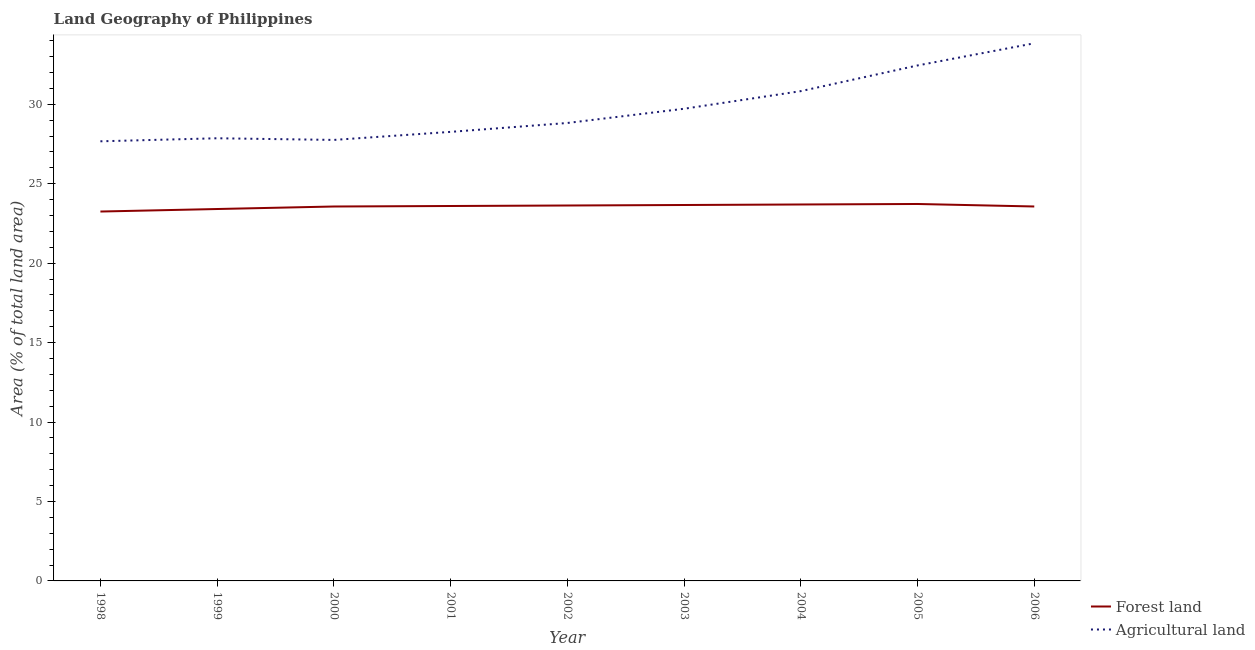Does the line corresponding to percentage of land area under forests intersect with the line corresponding to percentage of land area under agriculture?
Give a very brief answer. No. What is the percentage of land area under agriculture in 2004?
Give a very brief answer. 30.83. Across all years, what is the maximum percentage of land area under agriculture?
Offer a terse response. 33.84. Across all years, what is the minimum percentage of land area under forests?
Provide a succinct answer. 23.25. In which year was the percentage of land area under agriculture minimum?
Your response must be concise. 1998. What is the total percentage of land area under forests in the graph?
Ensure brevity in your answer.  212.1. What is the difference between the percentage of land area under agriculture in 1998 and that in 2002?
Provide a succinct answer. -1.15. What is the difference between the percentage of land area under agriculture in 2004 and the percentage of land area under forests in 1999?
Offer a terse response. 7.42. What is the average percentage of land area under agriculture per year?
Offer a very short reply. 29.69. In the year 2006, what is the difference between the percentage of land area under forests and percentage of land area under agriculture?
Your answer should be very brief. -10.27. In how many years, is the percentage of land area under agriculture greater than 9 %?
Provide a short and direct response. 9. What is the ratio of the percentage of land area under agriculture in 1998 to that in 2002?
Offer a terse response. 0.96. Is the percentage of land area under agriculture in 2000 less than that in 2002?
Ensure brevity in your answer.  Yes. Is the difference between the percentage of land area under agriculture in 1999 and 2004 greater than the difference between the percentage of land area under forests in 1999 and 2004?
Offer a very short reply. No. What is the difference between the highest and the second highest percentage of land area under forests?
Your response must be concise. 0.03. What is the difference between the highest and the lowest percentage of land area under agriculture?
Your response must be concise. 6.17. Is the sum of the percentage of land area under forests in 1999 and 2005 greater than the maximum percentage of land area under agriculture across all years?
Your answer should be compact. Yes. Does the percentage of land area under agriculture monotonically increase over the years?
Offer a terse response. No. Is the percentage of land area under forests strictly less than the percentage of land area under agriculture over the years?
Your answer should be compact. Yes. What is the difference between two consecutive major ticks on the Y-axis?
Offer a terse response. 5. Does the graph contain any zero values?
Your answer should be very brief. No. Does the graph contain grids?
Provide a succinct answer. No. Where does the legend appear in the graph?
Ensure brevity in your answer.  Bottom right. How many legend labels are there?
Provide a succinct answer. 2. How are the legend labels stacked?
Give a very brief answer. Vertical. What is the title of the graph?
Your answer should be compact. Land Geography of Philippines. Does "Forest land" appear as one of the legend labels in the graph?
Offer a terse response. Yes. What is the label or title of the X-axis?
Provide a short and direct response. Year. What is the label or title of the Y-axis?
Keep it short and to the point. Area (% of total land area). What is the Area (% of total land area) of Forest land in 1998?
Make the answer very short. 23.25. What is the Area (% of total land area) of Agricultural land in 1998?
Your response must be concise. 27.67. What is the Area (% of total land area) of Forest land in 1999?
Your response must be concise. 23.41. What is the Area (% of total land area) of Agricultural land in 1999?
Make the answer very short. 27.86. What is the Area (% of total land area) of Forest land in 2000?
Your answer should be compact. 23.57. What is the Area (% of total land area) of Agricultural land in 2000?
Your answer should be very brief. 27.76. What is the Area (% of total land area) in Forest land in 2001?
Offer a terse response. 23.6. What is the Area (% of total land area) of Agricultural land in 2001?
Your response must be concise. 28.26. What is the Area (% of total land area) in Forest land in 2002?
Your answer should be compact. 23.63. What is the Area (% of total land area) of Agricultural land in 2002?
Ensure brevity in your answer.  28.82. What is the Area (% of total land area) of Forest land in 2003?
Ensure brevity in your answer.  23.66. What is the Area (% of total land area) of Agricultural land in 2003?
Offer a very short reply. 29.72. What is the Area (% of total land area) of Forest land in 2004?
Offer a terse response. 23.69. What is the Area (% of total land area) of Agricultural land in 2004?
Make the answer very short. 30.83. What is the Area (% of total land area) in Forest land in 2005?
Offer a terse response. 23.72. What is the Area (% of total land area) of Agricultural land in 2005?
Provide a short and direct response. 32.44. What is the Area (% of total land area) of Forest land in 2006?
Ensure brevity in your answer.  23.57. What is the Area (% of total land area) of Agricultural land in 2006?
Your answer should be compact. 33.84. Across all years, what is the maximum Area (% of total land area) in Forest land?
Provide a succinct answer. 23.72. Across all years, what is the maximum Area (% of total land area) of Agricultural land?
Your answer should be very brief. 33.84. Across all years, what is the minimum Area (% of total land area) in Forest land?
Your answer should be compact. 23.25. Across all years, what is the minimum Area (% of total land area) of Agricultural land?
Your answer should be compact. 27.67. What is the total Area (% of total land area) in Forest land in the graph?
Give a very brief answer. 212.1. What is the total Area (% of total land area) in Agricultural land in the graph?
Your answer should be very brief. 267.21. What is the difference between the Area (% of total land area) of Forest land in 1998 and that in 1999?
Ensure brevity in your answer.  -0.16. What is the difference between the Area (% of total land area) in Agricultural land in 1998 and that in 1999?
Keep it short and to the point. -0.19. What is the difference between the Area (% of total land area) in Forest land in 1998 and that in 2000?
Your answer should be compact. -0.32. What is the difference between the Area (% of total land area) in Agricultural land in 1998 and that in 2000?
Provide a short and direct response. -0.09. What is the difference between the Area (% of total land area) in Forest land in 1998 and that in 2001?
Give a very brief answer. -0.35. What is the difference between the Area (% of total land area) of Agricultural land in 1998 and that in 2001?
Provide a succinct answer. -0.59. What is the difference between the Area (% of total land area) in Forest land in 1998 and that in 2002?
Offer a very short reply. -0.38. What is the difference between the Area (% of total land area) of Agricultural land in 1998 and that in 2002?
Offer a very short reply. -1.15. What is the difference between the Area (% of total land area) in Forest land in 1998 and that in 2003?
Make the answer very short. -0.41. What is the difference between the Area (% of total land area) in Agricultural land in 1998 and that in 2003?
Offer a terse response. -2.05. What is the difference between the Area (% of total land area) of Forest land in 1998 and that in 2004?
Make the answer very short. -0.44. What is the difference between the Area (% of total land area) in Agricultural land in 1998 and that in 2004?
Provide a succinct answer. -3.16. What is the difference between the Area (% of total land area) of Forest land in 1998 and that in 2005?
Your answer should be compact. -0.47. What is the difference between the Area (% of total land area) of Agricultural land in 1998 and that in 2005?
Keep it short and to the point. -4.77. What is the difference between the Area (% of total land area) of Forest land in 1998 and that in 2006?
Provide a short and direct response. -0.32. What is the difference between the Area (% of total land area) in Agricultural land in 1998 and that in 2006?
Ensure brevity in your answer.  -6.17. What is the difference between the Area (% of total land area) of Forest land in 1999 and that in 2000?
Your response must be concise. -0.16. What is the difference between the Area (% of total land area) of Agricultural land in 1999 and that in 2000?
Your response must be concise. 0.1. What is the difference between the Area (% of total land area) in Forest land in 1999 and that in 2001?
Offer a very short reply. -0.19. What is the difference between the Area (% of total land area) of Agricultural land in 1999 and that in 2001?
Your response must be concise. -0.4. What is the difference between the Area (% of total land area) in Forest land in 1999 and that in 2002?
Give a very brief answer. -0.22. What is the difference between the Area (% of total land area) in Agricultural land in 1999 and that in 2002?
Give a very brief answer. -0.96. What is the difference between the Area (% of total land area) of Forest land in 1999 and that in 2003?
Ensure brevity in your answer.  -0.25. What is the difference between the Area (% of total land area) of Agricultural land in 1999 and that in 2003?
Make the answer very short. -1.86. What is the difference between the Area (% of total land area) of Forest land in 1999 and that in 2004?
Offer a terse response. -0.28. What is the difference between the Area (% of total land area) of Agricultural land in 1999 and that in 2004?
Ensure brevity in your answer.  -2.97. What is the difference between the Area (% of total land area) in Forest land in 1999 and that in 2005?
Your response must be concise. -0.32. What is the difference between the Area (% of total land area) of Agricultural land in 1999 and that in 2005?
Your answer should be compact. -4.58. What is the difference between the Area (% of total land area) in Forest land in 1999 and that in 2006?
Provide a short and direct response. -0.16. What is the difference between the Area (% of total land area) in Agricultural land in 1999 and that in 2006?
Keep it short and to the point. -5.98. What is the difference between the Area (% of total land area) of Forest land in 2000 and that in 2001?
Your answer should be compact. -0.03. What is the difference between the Area (% of total land area) in Agricultural land in 2000 and that in 2001?
Give a very brief answer. -0.51. What is the difference between the Area (% of total land area) of Forest land in 2000 and that in 2002?
Make the answer very short. -0.06. What is the difference between the Area (% of total land area) of Agricultural land in 2000 and that in 2002?
Keep it short and to the point. -1.07. What is the difference between the Area (% of total land area) in Forest land in 2000 and that in 2003?
Make the answer very short. -0.09. What is the difference between the Area (% of total land area) of Agricultural land in 2000 and that in 2003?
Give a very brief answer. -1.96. What is the difference between the Area (% of total land area) in Forest land in 2000 and that in 2004?
Your response must be concise. -0.13. What is the difference between the Area (% of total land area) of Agricultural land in 2000 and that in 2004?
Ensure brevity in your answer.  -3.07. What is the difference between the Area (% of total land area) in Forest land in 2000 and that in 2005?
Offer a very short reply. -0.16. What is the difference between the Area (% of total land area) of Agricultural land in 2000 and that in 2005?
Keep it short and to the point. -4.69. What is the difference between the Area (% of total land area) of Forest land in 2000 and that in 2006?
Provide a succinct answer. -0. What is the difference between the Area (% of total land area) in Agricultural land in 2000 and that in 2006?
Offer a very short reply. -6.08. What is the difference between the Area (% of total land area) of Forest land in 2001 and that in 2002?
Your answer should be compact. -0.03. What is the difference between the Area (% of total land area) in Agricultural land in 2001 and that in 2002?
Provide a succinct answer. -0.56. What is the difference between the Area (% of total land area) of Forest land in 2001 and that in 2003?
Offer a terse response. -0.06. What is the difference between the Area (% of total land area) in Agricultural land in 2001 and that in 2003?
Your answer should be compact. -1.46. What is the difference between the Area (% of total land area) of Forest land in 2001 and that in 2004?
Keep it short and to the point. -0.09. What is the difference between the Area (% of total land area) in Agricultural land in 2001 and that in 2004?
Give a very brief answer. -2.56. What is the difference between the Area (% of total land area) in Forest land in 2001 and that in 2005?
Offer a terse response. -0.13. What is the difference between the Area (% of total land area) in Agricultural land in 2001 and that in 2005?
Make the answer very short. -4.18. What is the difference between the Area (% of total land area) of Forest land in 2001 and that in 2006?
Your answer should be compact. 0.03. What is the difference between the Area (% of total land area) of Agricultural land in 2001 and that in 2006?
Keep it short and to the point. -5.58. What is the difference between the Area (% of total land area) of Forest land in 2002 and that in 2003?
Your answer should be compact. -0.03. What is the difference between the Area (% of total land area) in Agricultural land in 2002 and that in 2003?
Offer a terse response. -0.9. What is the difference between the Area (% of total land area) of Forest land in 2002 and that in 2004?
Give a very brief answer. -0.06. What is the difference between the Area (% of total land area) of Agricultural land in 2002 and that in 2004?
Offer a terse response. -2. What is the difference between the Area (% of total land area) of Forest land in 2002 and that in 2005?
Provide a succinct answer. -0.09. What is the difference between the Area (% of total land area) in Agricultural land in 2002 and that in 2005?
Make the answer very short. -3.62. What is the difference between the Area (% of total land area) of Forest land in 2002 and that in 2006?
Your answer should be compact. 0.06. What is the difference between the Area (% of total land area) of Agricultural land in 2002 and that in 2006?
Keep it short and to the point. -5.02. What is the difference between the Area (% of total land area) of Forest land in 2003 and that in 2004?
Your answer should be compact. -0.03. What is the difference between the Area (% of total land area) in Agricultural land in 2003 and that in 2004?
Your response must be concise. -1.11. What is the difference between the Area (% of total land area) in Forest land in 2003 and that in 2005?
Provide a succinct answer. -0.06. What is the difference between the Area (% of total land area) in Agricultural land in 2003 and that in 2005?
Provide a short and direct response. -2.73. What is the difference between the Area (% of total land area) of Forest land in 2003 and that in 2006?
Your answer should be very brief. 0.09. What is the difference between the Area (% of total land area) in Agricultural land in 2003 and that in 2006?
Offer a terse response. -4.12. What is the difference between the Area (% of total land area) in Forest land in 2004 and that in 2005?
Provide a succinct answer. -0.03. What is the difference between the Area (% of total land area) in Agricultural land in 2004 and that in 2005?
Your answer should be very brief. -1.62. What is the difference between the Area (% of total land area) of Forest land in 2004 and that in 2006?
Your response must be concise. 0.13. What is the difference between the Area (% of total land area) of Agricultural land in 2004 and that in 2006?
Your answer should be compact. -3.01. What is the difference between the Area (% of total land area) of Forest land in 2005 and that in 2006?
Your response must be concise. 0.16. What is the difference between the Area (% of total land area) in Agricultural land in 2005 and that in 2006?
Make the answer very short. -1.4. What is the difference between the Area (% of total land area) of Forest land in 1998 and the Area (% of total land area) of Agricultural land in 1999?
Make the answer very short. -4.61. What is the difference between the Area (% of total land area) of Forest land in 1998 and the Area (% of total land area) of Agricultural land in 2000?
Ensure brevity in your answer.  -4.51. What is the difference between the Area (% of total land area) in Forest land in 1998 and the Area (% of total land area) in Agricultural land in 2001?
Give a very brief answer. -5.01. What is the difference between the Area (% of total land area) in Forest land in 1998 and the Area (% of total land area) in Agricultural land in 2002?
Provide a short and direct response. -5.57. What is the difference between the Area (% of total land area) in Forest land in 1998 and the Area (% of total land area) in Agricultural land in 2003?
Offer a terse response. -6.47. What is the difference between the Area (% of total land area) of Forest land in 1998 and the Area (% of total land area) of Agricultural land in 2004?
Keep it short and to the point. -7.58. What is the difference between the Area (% of total land area) of Forest land in 1998 and the Area (% of total land area) of Agricultural land in 2005?
Make the answer very short. -9.19. What is the difference between the Area (% of total land area) of Forest land in 1998 and the Area (% of total land area) of Agricultural land in 2006?
Provide a succinct answer. -10.59. What is the difference between the Area (% of total land area) in Forest land in 1999 and the Area (% of total land area) in Agricultural land in 2000?
Offer a terse response. -4.35. What is the difference between the Area (% of total land area) of Forest land in 1999 and the Area (% of total land area) of Agricultural land in 2001?
Ensure brevity in your answer.  -4.86. What is the difference between the Area (% of total land area) in Forest land in 1999 and the Area (% of total land area) in Agricultural land in 2002?
Ensure brevity in your answer.  -5.41. What is the difference between the Area (% of total land area) in Forest land in 1999 and the Area (% of total land area) in Agricultural land in 2003?
Keep it short and to the point. -6.31. What is the difference between the Area (% of total land area) of Forest land in 1999 and the Area (% of total land area) of Agricultural land in 2004?
Make the answer very short. -7.42. What is the difference between the Area (% of total land area) of Forest land in 1999 and the Area (% of total land area) of Agricultural land in 2005?
Ensure brevity in your answer.  -9.04. What is the difference between the Area (% of total land area) in Forest land in 1999 and the Area (% of total land area) in Agricultural land in 2006?
Your answer should be compact. -10.43. What is the difference between the Area (% of total land area) of Forest land in 2000 and the Area (% of total land area) of Agricultural land in 2001?
Make the answer very short. -4.7. What is the difference between the Area (% of total land area) in Forest land in 2000 and the Area (% of total land area) in Agricultural land in 2002?
Your answer should be very brief. -5.26. What is the difference between the Area (% of total land area) in Forest land in 2000 and the Area (% of total land area) in Agricultural land in 2003?
Provide a short and direct response. -6.15. What is the difference between the Area (% of total land area) in Forest land in 2000 and the Area (% of total land area) in Agricultural land in 2004?
Provide a short and direct response. -7.26. What is the difference between the Area (% of total land area) of Forest land in 2000 and the Area (% of total land area) of Agricultural land in 2005?
Make the answer very short. -8.88. What is the difference between the Area (% of total land area) in Forest land in 2000 and the Area (% of total land area) in Agricultural land in 2006?
Provide a succinct answer. -10.27. What is the difference between the Area (% of total land area) in Forest land in 2001 and the Area (% of total land area) in Agricultural land in 2002?
Give a very brief answer. -5.22. What is the difference between the Area (% of total land area) in Forest land in 2001 and the Area (% of total land area) in Agricultural land in 2003?
Ensure brevity in your answer.  -6.12. What is the difference between the Area (% of total land area) in Forest land in 2001 and the Area (% of total land area) in Agricultural land in 2004?
Offer a terse response. -7.23. What is the difference between the Area (% of total land area) of Forest land in 2001 and the Area (% of total land area) of Agricultural land in 2005?
Give a very brief answer. -8.85. What is the difference between the Area (% of total land area) of Forest land in 2001 and the Area (% of total land area) of Agricultural land in 2006?
Provide a succinct answer. -10.24. What is the difference between the Area (% of total land area) of Forest land in 2002 and the Area (% of total land area) of Agricultural land in 2003?
Keep it short and to the point. -6.09. What is the difference between the Area (% of total land area) of Forest land in 2002 and the Area (% of total land area) of Agricultural land in 2004?
Your answer should be very brief. -7.2. What is the difference between the Area (% of total land area) in Forest land in 2002 and the Area (% of total land area) in Agricultural land in 2005?
Ensure brevity in your answer.  -8.81. What is the difference between the Area (% of total land area) of Forest land in 2002 and the Area (% of total land area) of Agricultural land in 2006?
Your answer should be very brief. -10.21. What is the difference between the Area (% of total land area) in Forest land in 2003 and the Area (% of total land area) in Agricultural land in 2004?
Keep it short and to the point. -7.17. What is the difference between the Area (% of total land area) in Forest land in 2003 and the Area (% of total land area) in Agricultural land in 2005?
Give a very brief answer. -8.78. What is the difference between the Area (% of total land area) of Forest land in 2003 and the Area (% of total land area) of Agricultural land in 2006?
Make the answer very short. -10.18. What is the difference between the Area (% of total land area) of Forest land in 2004 and the Area (% of total land area) of Agricultural land in 2005?
Your answer should be compact. -8.75. What is the difference between the Area (% of total land area) of Forest land in 2004 and the Area (% of total land area) of Agricultural land in 2006?
Ensure brevity in your answer.  -10.15. What is the difference between the Area (% of total land area) in Forest land in 2005 and the Area (% of total land area) in Agricultural land in 2006?
Keep it short and to the point. -10.12. What is the average Area (% of total land area) in Forest land per year?
Provide a short and direct response. 23.57. What is the average Area (% of total land area) of Agricultural land per year?
Ensure brevity in your answer.  29.69. In the year 1998, what is the difference between the Area (% of total land area) in Forest land and Area (% of total land area) in Agricultural land?
Your answer should be very brief. -4.42. In the year 1999, what is the difference between the Area (% of total land area) in Forest land and Area (% of total land area) in Agricultural land?
Offer a very short reply. -4.45. In the year 2000, what is the difference between the Area (% of total land area) of Forest land and Area (% of total land area) of Agricultural land?
Offer a terse response. -4.19. In the year 2001, what is the difference between the Area (% of total land area) in Forest land and Area (% of total land area) in Agricultural land?
Keep it short and to the point. -4.67. In the year 2002, what is the difference between the Area (% of total land area) in Forest land and Area (% of total land area) in Agricultural land?
Ensure brevity in your answer.  -5.19. In the year 2003, what is the difference between the Area (% of total land area) in Forest land and Area (% of total land area) in Agricultural land?
Make the answer very short. -6.06. In the year 2004, what is the difference between the Area (% of total land area) of Forest land and Area (% of total land area) of Agricultural land?
Make the answer very short. -7.13. In the year 2005, what is the difference between the Area (% of total land area) in Forest land and Area (% of total land area) in Agricultural land?
Offer a terse response. -8.72. In the year 2006, what is the difference between the Area (% of total land area) of Forest land and Area (% of total land area) of Agricultural land?
Offer a very short reply. -10.27. What is the ratio of the Area (% of total land area) in Forest land in 1998 to that in 1999?
Your answer should be very brief. 0.99. What is the ratio of the Area (% of total land area) in Forest land in 1998 to that in 2000?
Give a very brief answer. 0.99. What is the ratio of the Area (% of total land area) in Agricultural land in 1998 to that in 2000?
Your response must be concise. 1. What is the ratio of the Area (% of total land area) of Forest land in 1998 to that in 2001?
Ensure brevity in your answer.  0.99. What is the ratio of the Area (% of total land area) in Agricultural land in 1998 to that in 2001?
Offer a very short reply. 0.98. What is the ratio of the Area (% of total land area) in Forest land in 1998 to that in 2002?
Keep it short and to the point. 0.98. What is the ratio of the Area (% of total land area) of Forest land in 1998 to that in 2003?
Provide a short and direct response. 0.98. What is the ratio of the Area (% of total land area) of Agricultural land in 1998 to that in 2003?
Keep it short and to the point. 0.93. What is the ratio of the Area (% of total land area) in Forest land in 1998 to that in 2004?
Provide a short and direct response. 0.98. What is the ratio of the Area (% of total land area) of Agricultural land in 1998 to that in 2004?
Provide a short and direct response. 0.9. What is the ratio of the Area (% of total land area) of Agricultural land in 1998 to that in 2005?
Your response must be concise. 0.85. What is the ratio of the Area (% of total land area) of Forest land in 1998 to that in 2006?
Your answer should be very brief. 0.99. What is the ratio of the Area (% of total land area) in Agricultural land in 1998 to that in 2006?
Keep it short and to the point. 0.82. What is the ratio of the Area (% of total land area) of Forest land in 1999 to that in 2000?
Offer a terse response. 0.99. What is the ratio of the Area (% of total land area) in Agricultural land in 1999 to that in 2001?
Your answer should be very brief. 0.99. What is the ratio of the Area (% of total land area) of Forest land in 1999 to that in 2002?
Ensure brevity in your answer.  0.99. What is the ratio of the Area (% of total land area) in Agricultural land in 1999 to that in 2002?
Your answer should be very brief. 0.97. What is the ratio of the Area (% of total land area) in Forest land in 1999 to that in 2003?
Keep it short and to the point. 0.99. What is the ratio of the Area (% of total land area) of Agricultural land in 1999 to that in 2004?
Provide a succinct answer. 0.9. What is the ratio of the Area (% of total land area) of Forest land in 1999 to that in 2005?
Make the answer very short. 0.99. What is the ratio of the Area (% of total land area) of Agricultural land in 1999 to that in 2005?
Your response must be concise. 0.86. What is the ratio of the Area (% of total land area) of Agricultural land in 1999 to that in 2006?
Ensure brevity in your answer.  0.82. What is the ratio of the Area (% of total land area) in Agricultural land in 2000 to that in 2001?
Provide a succinct answer. 0.98. What is the ratio of the Area (% of total land area) of Forest land in 2000 to that in 2003?
Your response must be concise. 1. What is the ratio of the Area (% of total land area) in Agricultural land in 2000 to that in 2003?
Provide a short and direct response. 0.93. What is the ratio of the Area (% of total land area) of Forest land in 2000 to that in 2004?
Provide a succinct answer. 0.99. What is the ratio of the Area (% of total land area) of Agricultural land in 2000 to that in 2004?
Offer a terse response. 0.9. What is the ratio of the Area (% of total land area) in Agricultural land in 2000 to that in 2005?
Offer a terse response. 0.86. What is the ratio of the Area (% of total land area) in Forest land in 2000 to that in 2006?
Your response must be concise. 1. What is the ratio of the Area (% of total land area) of Agricultural land in 2000 to that in 2006?
Keep it short and to the point. 0.82. What is the ratio of the Area (% of total land area) in Forest land in 2001 to that in 2002?
Offer a terse response. 1. What is the ratio of the Area (% of total land area) in Agricultural land in 2001 to that in 2002?
Provide a short and direct response. 0.98. What is the ratio of the Area (% of total land area) of Forest land in 2001 to that in 2003?
Offer a terse response. 1. What is the ratio of the Area (% of total land area) of Agricultural land in 2001 to that in 2003?
Offer a terse response. 0.95. What is the ratio of the Area (% of total land area) in Forest land in 2001 to that in 2004?
Provide a short and direct response. 1. What is the ratio of the Area (% of total land area) in Agricultural land in 2001 to that in 2004?
Ensure brevity in your answer.  0.92. What is the ratio of the Area (% of total land area) in Agricultural land in 2001 to that in 2005?
Ensure brevity in your answer.  0.87. What is the ratio of the Area (% of total land area) of Forest land in 2001 to that in 2006?
Give a very brief answer. 1. What is the ratio of the Area (% of total land area) of Agricultural land in 2001 to that in 2006?
Provide a succinct answer. 0.84. What is the ratio of the Area (% of total land area) of Agricultural land in 2002 to that in 2003?
Make the answer very short. 0.97. What is the ratio of the Area (% of total land area) in Agricultural land in 2002 to that in 2004?
Offer a very short reply. 0.94. What is the ratio of the Area (% of total land area) in Agricultural land in 2002 to that in 2005?
Ensure brevity in your answer.  0.89. What is the ratio of the Area (% of total land area) of Forest land in 2002 to that in 2006?
Provide a succinct answer. 1. What is the ratio of the Area (% of total land area) in Agricultural land in 2002 to that in 2006?
Ensure brevity in your answer.  0.85. What is the ratio of the Area (% of total land area) in Agricultural land in 2003 to that in 2004?
Make the answer very short. 0.96. What is the ratio of the Area (% of total land area) of Forest land in 2003 to that in 2005?
Your answer should be very brief. 1. What is the ratio of the Area (% of total land area) in Agricultural land in 2003 to that in 2005?
Offer a very short reply. 0.92. What is the ratio of the Area (% of total land area) in Forest land in 2003 to that in 2006?
Your response must be concise. 1. What is the ratio of the Area (% of total land area) in Agricultural land in 2003 to that in 2006?
Offer a terse response. 0.88. What is the ratio of the Area (% of total land area) of Agricultural land in 2004 to that in 2005?
Your answer should be very brief. 0.95. What is the ratio of the Area (% of total land area) of Forest land in 2004 to that in 2006?
Offer a terse response. 1.01. What is the ratio of the Area (% of total land area) of Agricultural land in 2004 to that in 2006?
Provide a succinct answer. 0.91. What is the ratio of the Area (% of total land area) of Forest land in 2005 to that in 2006?
Your response must be concise. 1.01. What is the ratio of the Area (% of total land area) of Agricultural land in 2005 to that in 2006?
Keep it short and to the point. 0.96. What is the difference between the highest and the second highest Area (% of total land area) of Forest land?
Offer a very short reply. 0.03. What is the difference between the highest and the second highest Area (% of total land area) in Agricultural land?
Make the answer very short. 1.4. What is the difference between the highest and the lowest Area (% of total land area) in Forest land?
Make the answer very short. 0.47. What is the difference between the highest and the lowest Area (% of total land area) of Agricultural land?
Your answer should be compact. 6.17. 